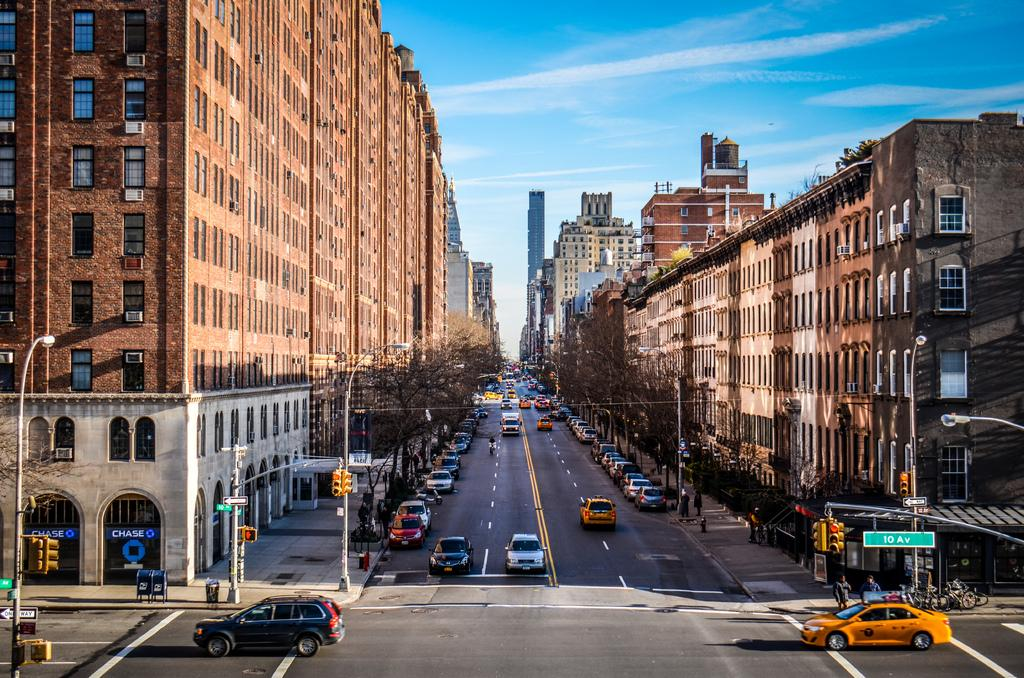<image>
Summarize the visual content of the image. Chase Bank is on the corner of 10th Avenue, which is a one way street. 